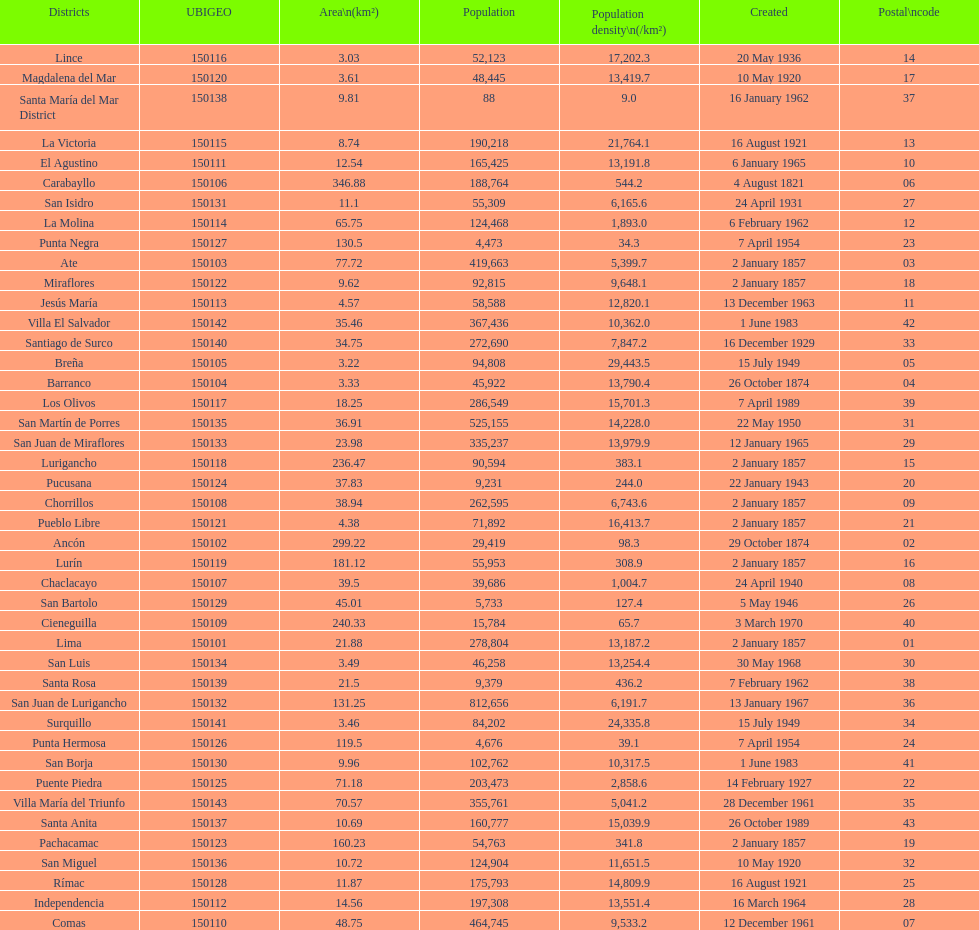How many districts have a population density of at lest 1000.0? 31. 